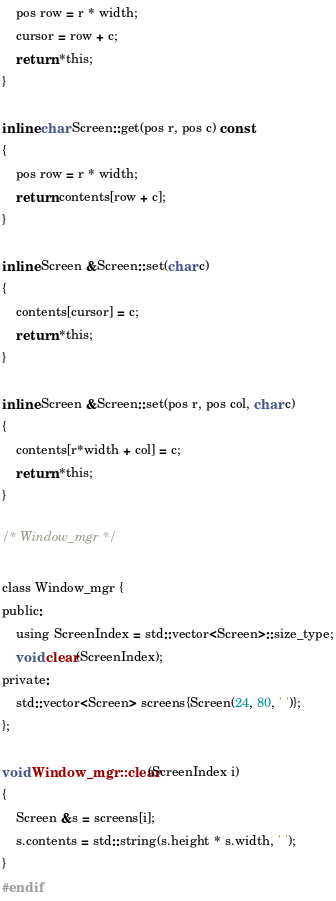<code> <loc_0><loc_0><loc_500><loc_500><_C_>    pos row = r * width;
    cursor = row + c;
    return *this;
}

inline char Screen::get(pos r, pos c) const
{
    pos row = r * width;
    return contents[row + c];
}

inline Screen &Screen::set(char c)
{
    contents[cursor] = c;
    return *this;
}

inline Screen &Screen::set(pos r, pos col, char c)
{
    contents[r*width + col] = c;
    return *this;
}

/* Window_mgr */

class Window_mgr {
public:
    using ScreenIndex = std::vector<Screen>::size_type;
    void clear(ScreenIndex);
private:
    std::vector<Screen> screens{Screen(24, 80, ' ')};
};

void Window_mgr::clear(ScreenIndex i)
{
    Screen &s = screens[i];
    s.contents = std::string(s.height * s.width, ' ');
}
#endif
</code> 